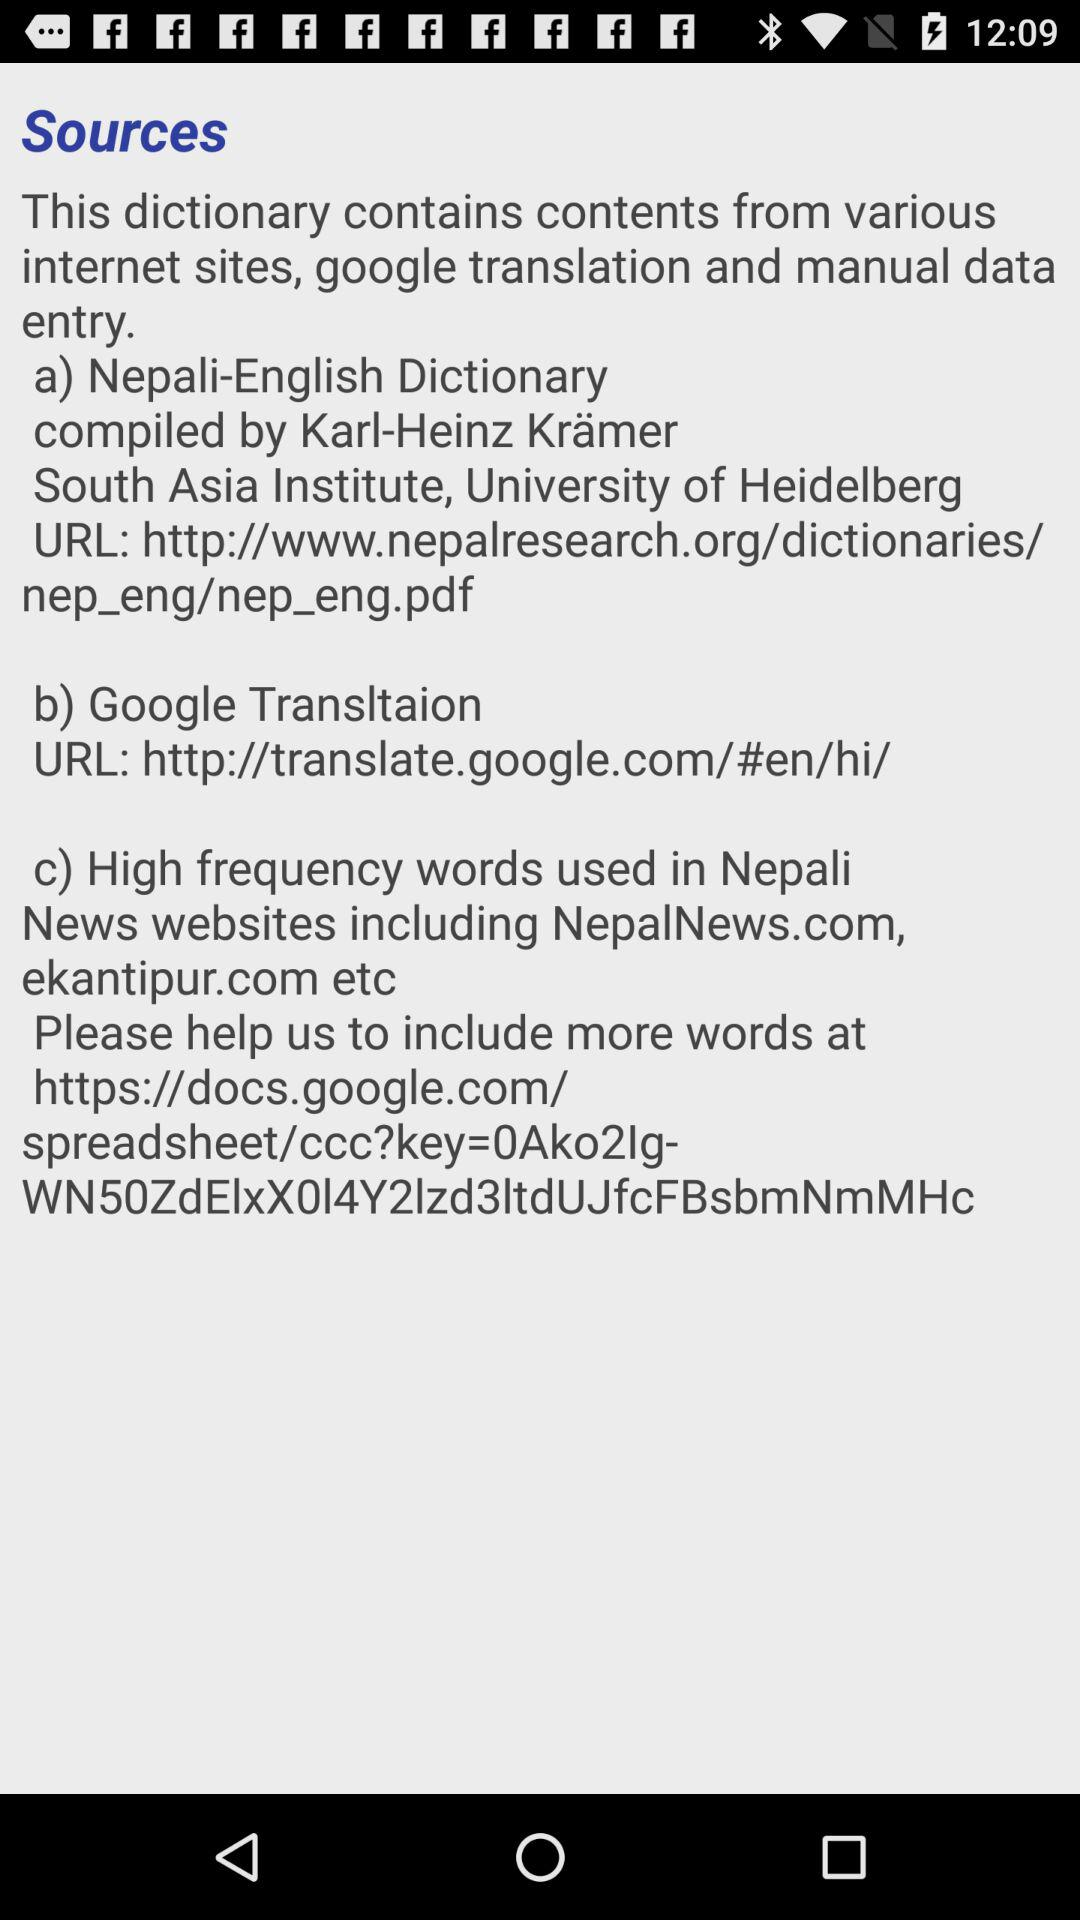How many links to external websites are there?
Answer the question using a single word or phrase. 3 